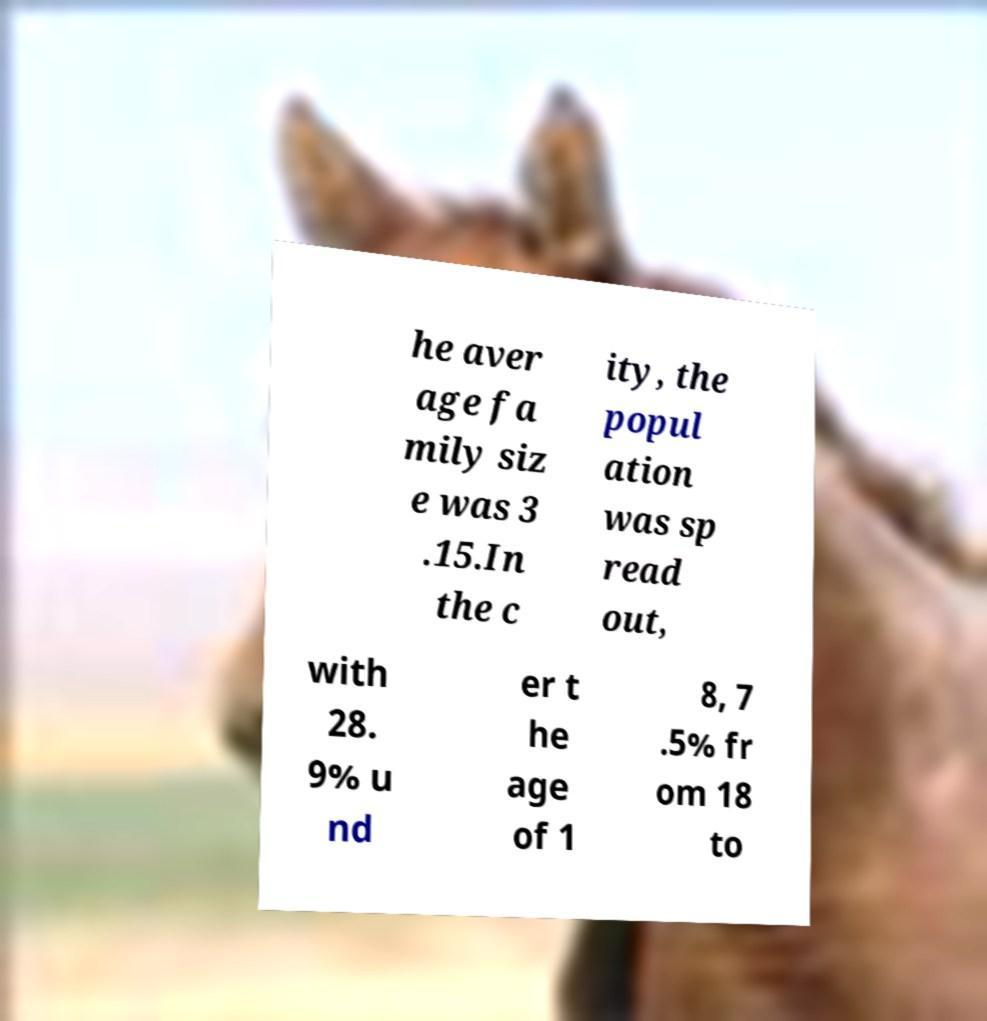I need the written content from this picture converted into text. Can you do that? he aver age fa mily siz e was 3 .15.In the c ity, the popul ation was sp read out, with 28. 9% u nd er t he age of 1 8, 7 .5% fr om 18 to 